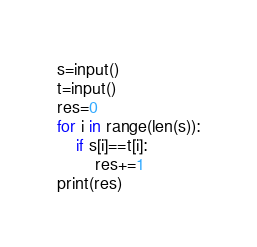Convert code to text. <code><loc_0><loc_0><loc_500><loc_500><_Python_>s=input()
t=input()
res=0
for i in range(len(s)):
	if s[i]==t[i]:
		res+=1
print(res)</code> 